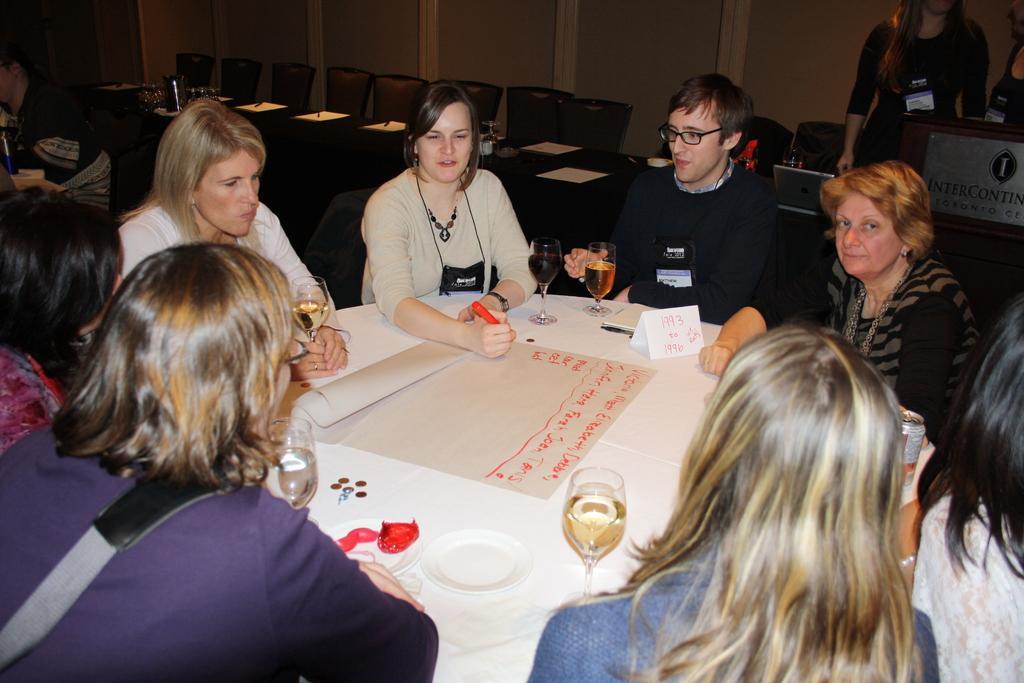In one or two sentences, can you explain what this image depicts? This is image consist of group of people sit around the table. A woman wearing a gray color jacket and discussing a topic and she holding a red color pen. And Beside her a man holding a glass of drink and there are of the some chairs kept on the back ground of the image. on the left corner a person sit on the chair. 